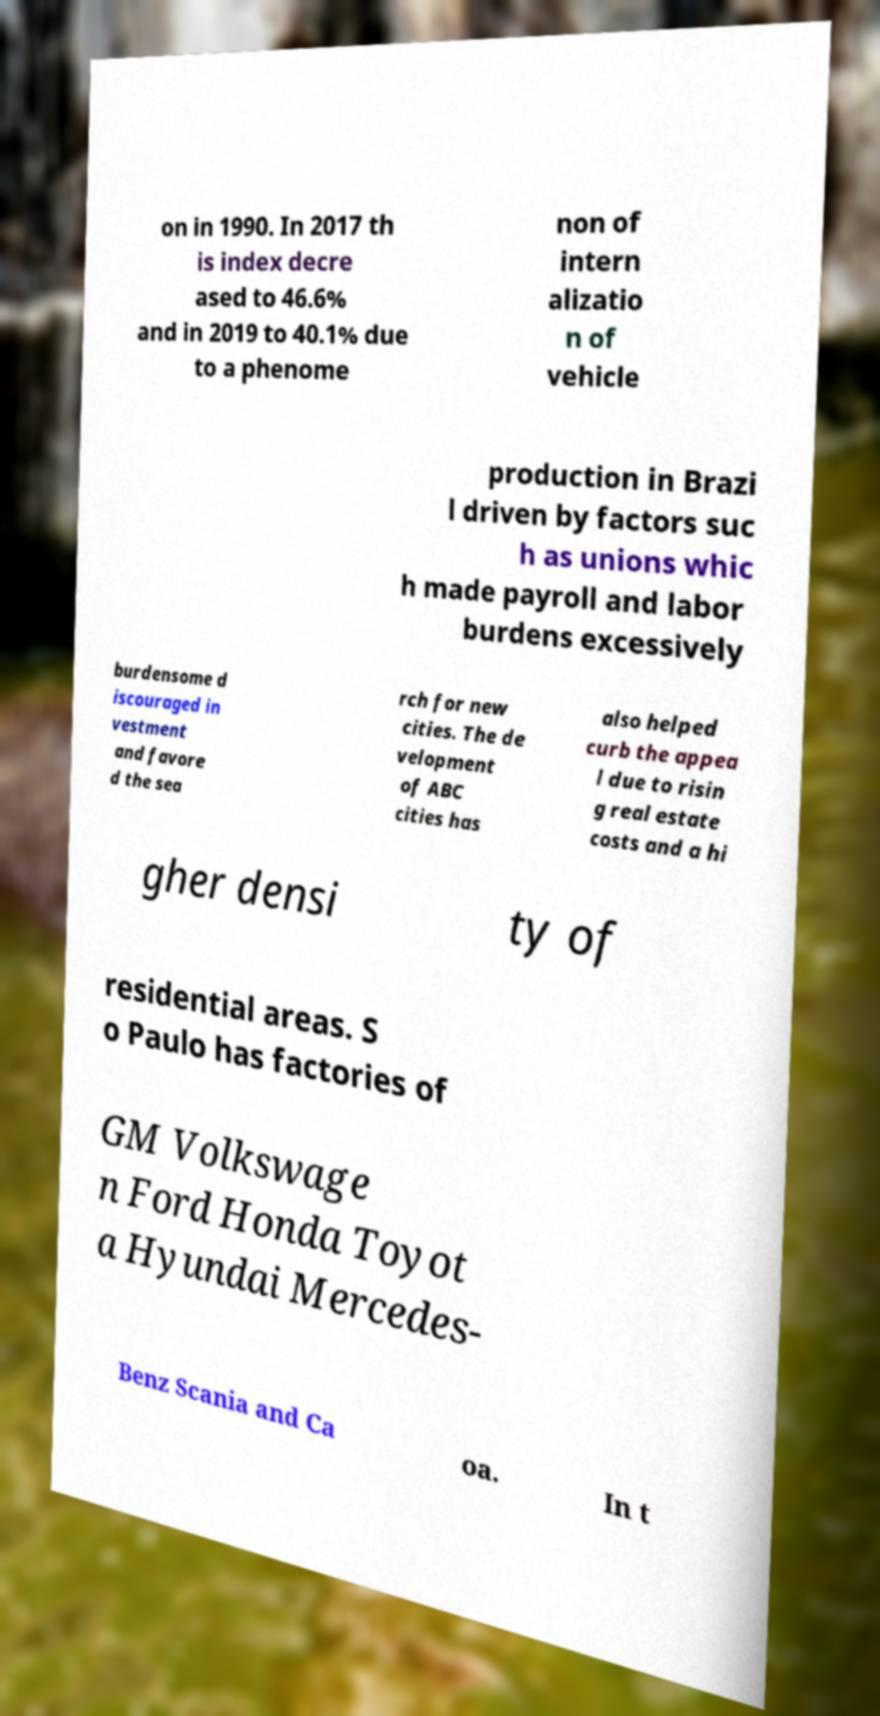For documentation purposes, I need the text within this image transcribed. Could you provide that? on in 1990. In 2017 th is index decre ased to 46.6% and in 2019 to 40.1% due to a phenome non of intern alizatio n of vehicle production in Brazi l driven by factors suc h as unions whic h made payroll and labor burdens excessively burdensome d iscouraged in vestment and favore d the sea rch for new cities. The de velopment of ABC cities has also helped curb the appea l due to risin g real estate costs and a hi gher densi ty of residential areas. S o Paulo has factories of GM Volkswage n Ford Honda Toyot a Hyundai Mercedes- Benz Scania and Ca oa. In t 